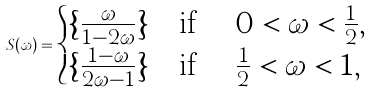Convert formula to latex. <formula><loc_0><loc_0><loc_500><loc_500>S ( \omega ) = \begin{cases} \{ \frac { \omega } { 1 - 2 \omega } \} & \text {if $\quad 0<\omega < \frac{1}{2}$} , \\ \{ \frac { 1 - \omega } { 2 \omega - 1 } \} & \text {if $\quad \frac{1}{2} < \omega <1 $} , \end{cases}</formula> 